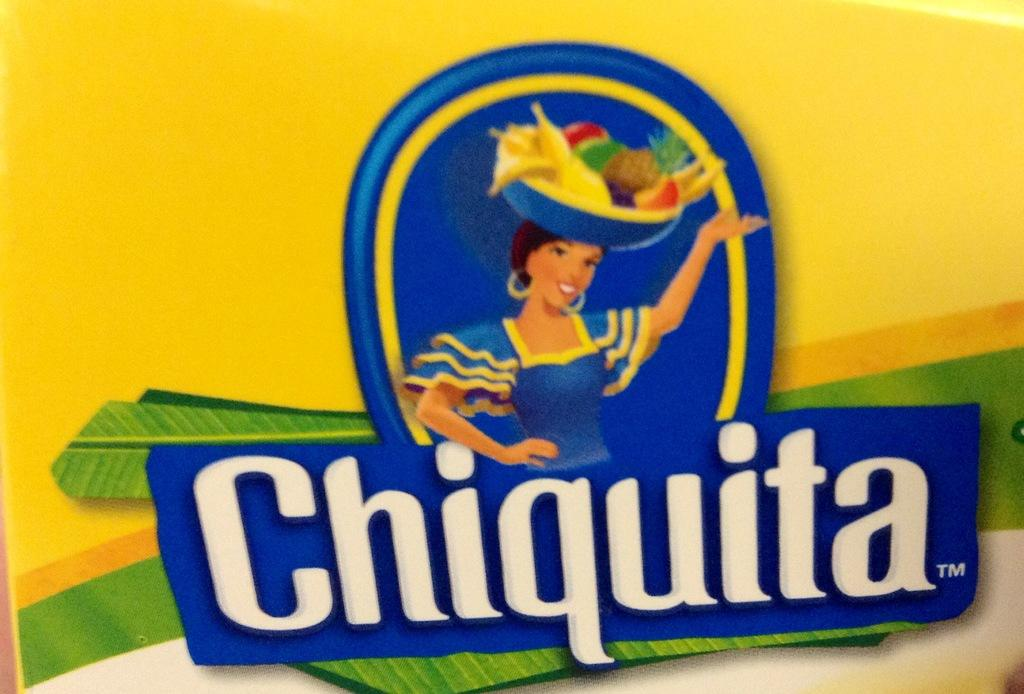What is depicted in the animated picture in the image? There is an animated picture of a woman in the image. What is the woman holding in the picture? The woman is holding a basket in the picture. What can be found inside the basket? The basket contains fruits. Is there any text associated with the image? Yes, there is text under the picture. Where is the library located in the image? There is no library present in the image. What type of plantation can be seen in the background of the image? There is no plantation visible in the image; it features an animated picture of a woman holding a basket of fruits. 